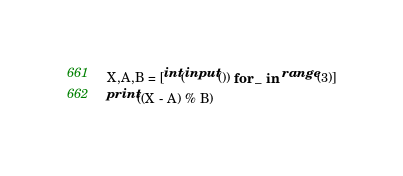<code> <loc_0><loc_0><loc_500><loc_500><_Python_>X,A,B = [int(input()) for _ in range(3)]
print((X - A) % B)</code> 